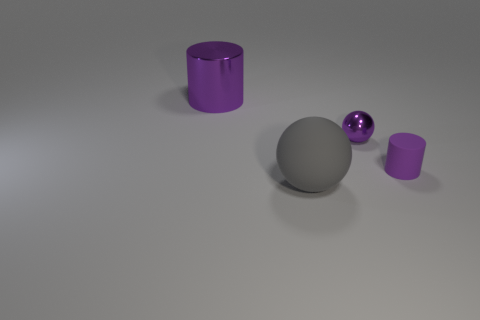How many purple matte things are to the left of the small purple shiny object on the left side of the purple cylinder that is right of the large metallic cylinder?
Offer a terse response. 0. Does the ball that is behind the big gray ball have the same size as the sphere in front of the small cylinder?
Make the answer very short. No. What is the material of the purple object that is the same shape as the big gray object?
Keep it short and to the point. Metal. How many small things are gray spheres or green metallic things?
Ensure brevity in your answer.  0. What is the material of the large cylinder?
Provide a short and direct response. Metal. There is a object that is both left of the metallic ball and on the right side of the large shiny object; what is its material?
Offer a terse response. Rubber. Do the tiny matte object and the metallic object on the left side of the purple sphere have the same color?
Your answer should be very brief. Yes. There is a cylinder that is the same size as the matte sphere; what material is it?
Your response must be concise. Metal. Is there a tiny cylinder that has the same material as the big purple cylinder?
Make the answer very short. No. How many tiny red rubber blocks are there?
Offer a very short reply. 0. 